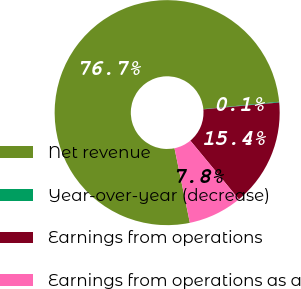Convert chart to OTSL. <chart><loc_0><loc_0><loc_500><loc_500><pie_chart><fcel>Net revenue<fcel>Year-over-year (decrease)<fcel>Earnings from operations<fcel>Earnings from operations as a<nl><fcel>76.7%<fcel>0.11%<fcel>15.43%<fcel>7.77%<nl></chart> 